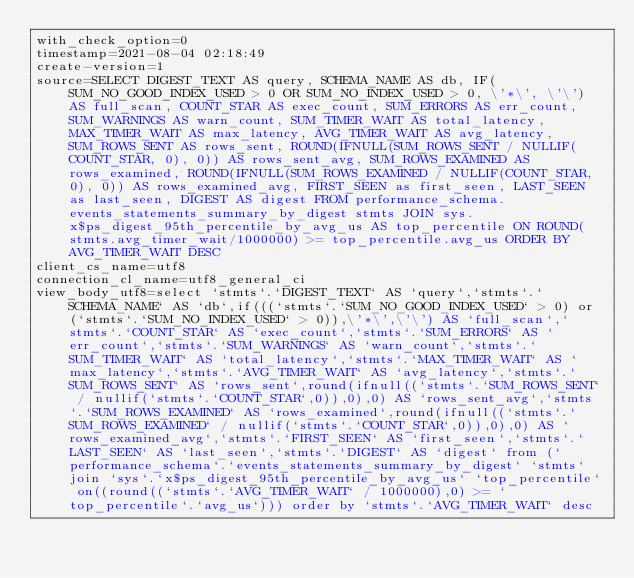Convert code to text. <code><loc_0><loc_0><loc_500><loc_500><_VisualBasic_>with_check_option=0
timestamp=2021-08-04 02:18:49
create-version=1
source=SELECT DIGEST_TEXT AS query, SCHEMA_NAME AS db, IF(SUM_NO_GOOD_INDEX_USED > 0 OR SUM_NO_INDEX_USED > 0, \'*\', \'\') AS full_scan, COUNT_STAR AS exec_count, SUM_ERRORS AS err_count, SUM_WARNINGS AS warn_count, SUM_TIMER_WAIT AS total_latency, MAX_TIMER_WAIT AS max_latency, AVG_TIMER_WAIT AS avg_latency, SUM_ROWS_SENT AS rows_sent, ROUND(IFNULL(SUM_ROWS_SENT / NULLIF(COUNT_STAR, 0), 0)) AS rows_sent_avg, SUM_ROWS_EXAMINED AS rows_examined, ROUND(IFNULL(SUM_ROWS_EXAMINED / NULLIF(COUNT_STAR, 0), 0)) AS rows_examined_avg, FIRST_SEEN as first_seen, LAST_SEEN as last_seen, DIGEST AS digest FROM performance_schema.events_statements_summary_by_digest stmts JOIN sys.x$ps_digest_95th_percentile_by_avg_us AS top_percentile ON ROUND(stmts.avg_timer_wait/1000000) >= top_percentile.avg_us ORDER BY AVG_TIMER_WAIT DESC
client_cs_name=utf8
connection_cl_name=utf8_general_ci
view_body_utf8=select `stmts`.`DIGEST_TEXT` AS `query`,`stmts`.`SCHEMA_NAME` AS `db`,if(((`stmts`.`SUM_NO_GOOD_INDEX_USED` > 0) or (`stmts`.`SUM_NO_INDEX_USED` > 0)),\'*\',\'\') AS `full_scan`,`stmts`.`COUNT_STAR` AS `exec_count`,`stmts`.`SUM_ERRORS` AS `err_count`,`stmts`.`SUM_WARNINGS` AS `warn_count`,`stmts`.`SUM_TIMER_WAIT` AS `total_latency`,`stmts`.`MAX_TIMER_WAIT` AS `max_latency`,`stmts`.`AVG_TIMER_WAIT` AS `avg_latency`,`stmts`.`SUM_ROWS_SENT` AS `rows_sent`,round(ifnull((`stmts`.`SUM_ROWS_SENT` / nullif(`stmts`.`COUNT_STAR`,0)),0),0) AS `rows_sent_avg`,`stmts`.`SUM_ROWS_EXAMINED` AS `rows_examined`,round(ifnull((`stmts`.`SUM_ROWS_EXAMINED` / nullif(`stmts`.`COUNT_STAR`,0)),0),0) AS `rows_examined_avg`,`stmts`.`FIRST_SEEN` AS `first_seen`,`stmts`.`LAST_SEEN` AS `last_seen`,`stmts`.`DIGEST` AS `digest` from (`performance_schema`.`events_statements_summary_by_digest` `stmts` join `sys`.`x$ps_digest_95th_percentile_by_avg_us` `top_percentile` on((round((`stmts`.`AVG_TIMER_WAIT` / 1000000),0) >= `top_percentile`.`avg_us`))) order by `stmts`.`AVG_TIMER_WAIT` desc
</code> 